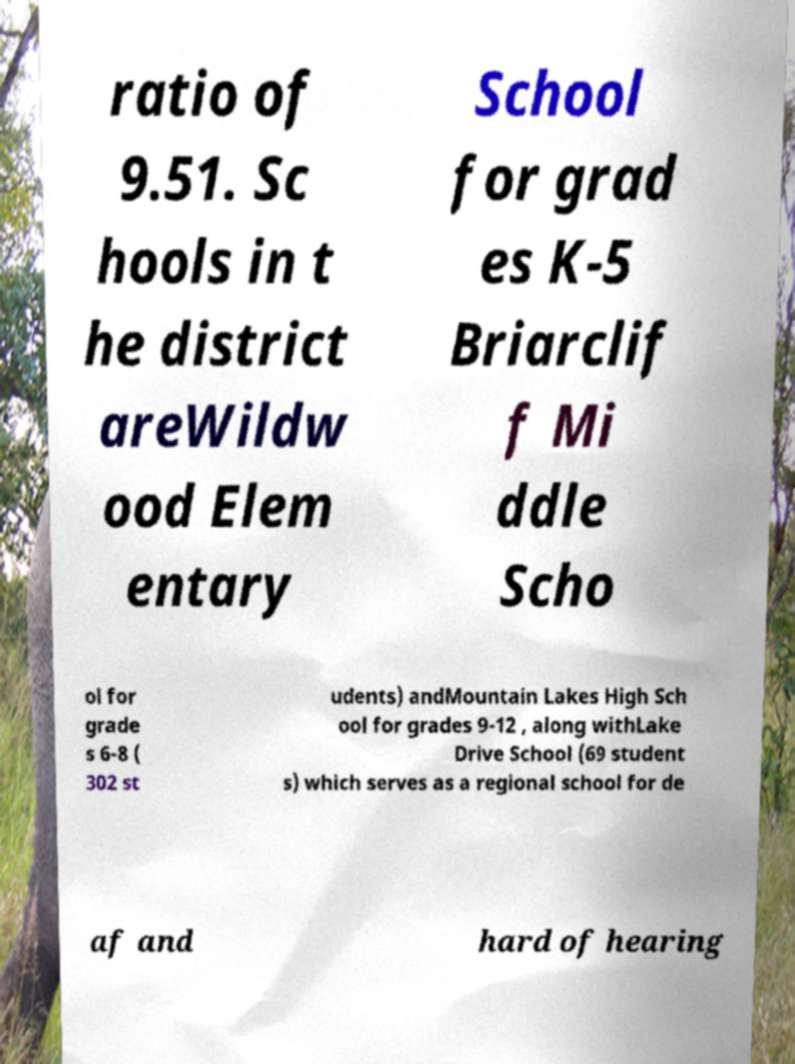Could you extract and type out the text from this image? ratio of 9.51. Sc hools in t he district areWildw ood Elem entary School for grad es K-5 Briarclif f Mi ddle Scho ol for grade s 6-8 ( 302 st udents) andMountain Lakes High Sch ool for grades 9-12 , along withLake Drive School (69 student s) which serves as a regional school for de af and hard of hearing 